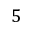Convert formula to latex. <formula><loc_0><loc_0><loc_500><loc_500>5</formula> 